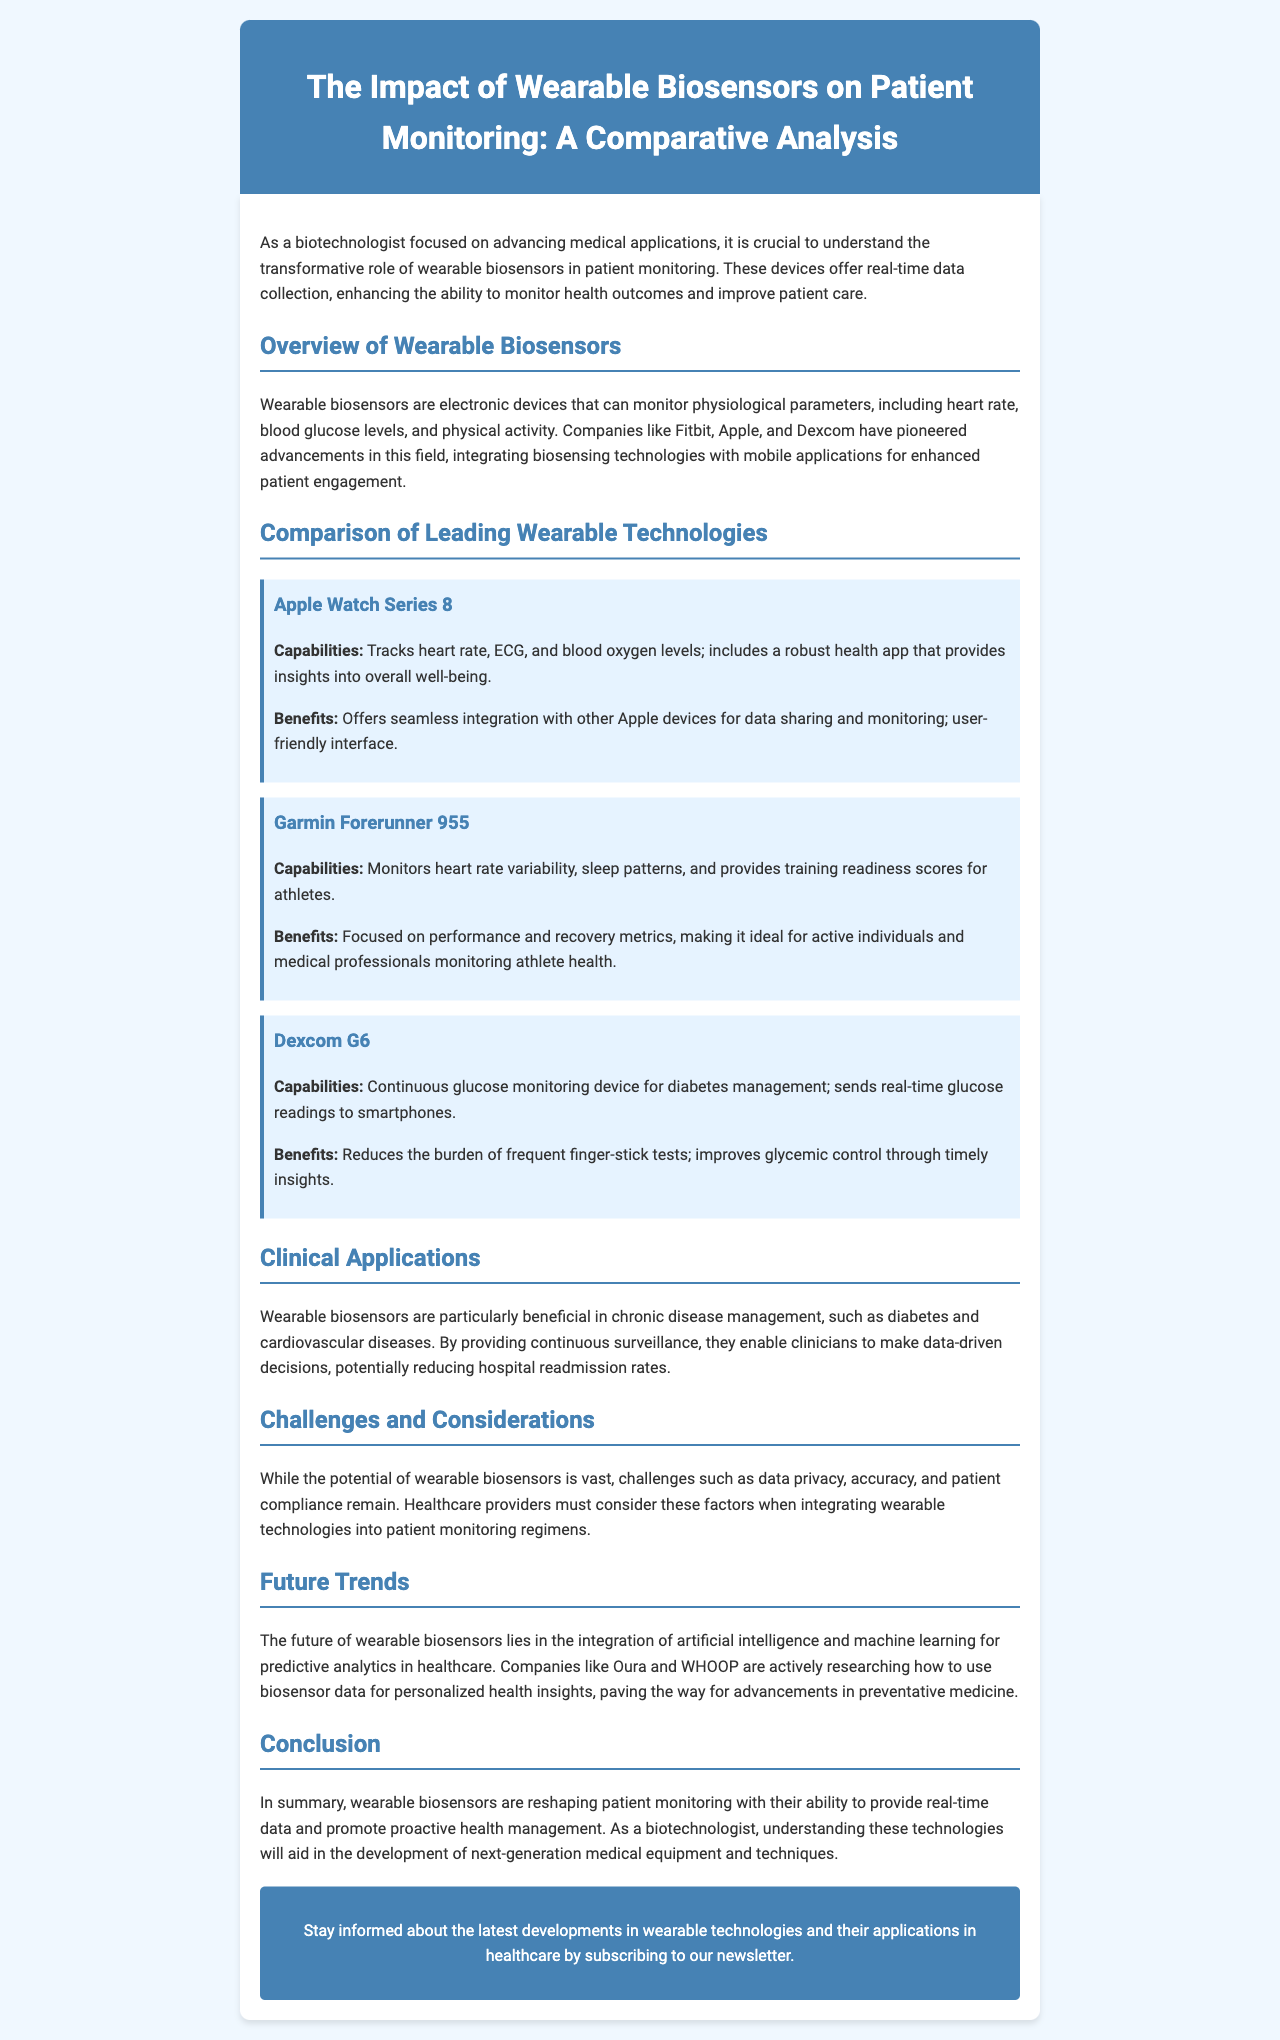What are wearable biosensors? Wearable biosensors are electronic devices that can monitor physiological parameters, including heart rate, blood glucose levels, and physical activity.
Answer: Electronic devices Who are leading companies in the wearable biosensor field? Companies like Fitbit, Apple, and Dexcom have pioneered advancements in this field.
Answer: Fitbit, Apple, Dexcom What capability does the Dexcom G6 offer? The Dexcom G6 is a continuous glucose monitoring device for diabetes management; it sends real-time glucose readings to smartphones.
Answer: Continuous glucose monitoring What benefit does the Apple Watch Series 8 provide? The Apple Watch Series 8 offers seamless integration with other Apple devices for data sharing and monitoring.
Answer: Seamless integration In which clinical areas are wearable biosensors particularly beneficial? Wearable biosensors are particularly beneficial in chronic disease management, such as diabetes and cardiovascular diseases.
Answer: Chronic disease management What challenges are associated with wearable biosensors? Challenges include data privacy, accuracy, and patient compliance.
Answer: Data privacy, accuracy, patient compliance What is the future trend mentioned for wearable biosensors? The future of wearable biosensors lies in the integration of artificial intelligence and machine learning for predictive analytics in healthcare.
Answer: Artificial intelligence and machine learning What is the purpose of the newsletter? The newsletter aims to keep readers informed about the latest developments in wearable technologies and their applications in healthcare.
Answer: Stay informed 